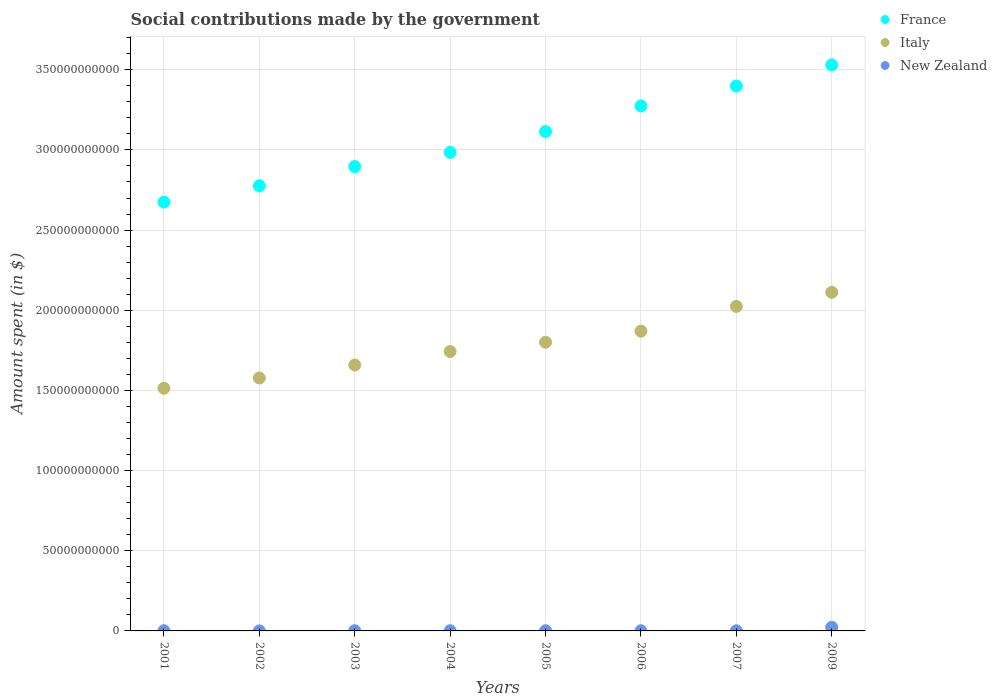How many different coloured dotlines are there?
Ensure brevity in your answer.  3. Is the number of dotlines equal to the number of legend labels?
Offer a very short reply. Yes. What is the amount spent on social contributions in Italy in 2002?
Your answer should be very brief. 1.58e+11. Across all years, what is the maximum amount spent on social contributions in Italy?
Ensure brevity in your answer.  2.11e+11. Across all years, what is the minimum amount spent on social contributions in France?
Ensure brevity in your answer.  2.67e+11. In which year was the amount spent on social contributions in Italy maximum?
Provide a succinct answer. 2009. What is the total amount spent on social contributions in France in the graph?
Offer a terse response. 2.46e+12. What is the difference between the amount spent on social contributions in France in 2005 and that in 2006?
Provide a short and direct response. -1.60e+1. What is the difference between the amount spent on social contributions in Italy in 2002 and the amount spent on social contributions in France in 2007?
Your answer should be compact. -1.82e+11. What is the average amount spent on social contributions in New Zealand per year?
Make the answer very short. 3.73e+08. In the year 2007, what is the difference between the amount spent on social contributions in New Zealand and amount spent on social contributions in France?
Your response must be concise. -3.40e+11. What is the ratio of the amount spent on social contributions in Italy in 2001 to that in 2009?
Your answer should be very brief. 0.72. Is the amount spent on social contributions in France in 2006 less than that in 2009?
Ensure brevity in your answer.  Yes. Is the difference between the amount spent on social contributions in New Zealand in 2006 and 2007 greater than the difference between the amount spent on social contributions in France in 2006 and 2007?
Give a very brief answer. Yes. What is the difference between the highest and the second highest amount spent on social contributions in Italy?
Offer a terse response. 8.82e+09. What is the difference between the highest and the lowest amount spent on social contributions in New Zealand?
Offer a terse response. 2.25e+09. In how many years, is the amount spent on social contributions in France greater than the average amount spent on social contributions in France taken over all years?
Your answer should be very brief. 4. Is the sum of the amount spent on social contributions in New Zealand in 2002 and 2009 greater than the maximum amount spent on social contributions in Italy across all years?
Make the answer very short. No. Is it the case that in every year, the sum of the amount spent on social contributions in France and amount spent on social contributions in New Zealand  is greater than the amount spent on social contributions in Italy?
Ensure brevity in your answer.  Yes. Is the amount spent on social contributions in France strictly less than the amount spent on social contributions in Italy over the years?
Give a very brief answer. No. How many dotlines are there?
Offer a terse response. 3. What is the difference between two consecutive major ticks on the Y-axis?
Your response must be concise. 5.00e+1. Are the values on the major ticks of Y-axis written in scientific E-notation?
Offer a very short reply. No. Does the graph contain any zero values?
Offer a very short reply. No. Does the graph contain grids?
Your answer should be very brief. Yes. How are the legend labels stacked?
Offer a terse response. Vertical. What is the title of the graph?
Your answer should be compact. Social contributions made by the government. What is the label or title of the Y-axis?
Keep it short and to the point. Amount spent (in $). What is the Amount spent (in $) in France in 2001?
Provide a succinct answer. 2.67e+11. What is the Amount spent (in $) of Italy in 2001?
Ensure brevity in your answer.  1.51e+11. What is the Amount spent (in $) in New Zealand in 2001?
Make the answer very short. 1.20e+08. What is the Amount spent (in $) of France in 2002?
Provide a short and direct response. 2.78e+11. What is the Amount spent (in $) in Italy in 2002?
Your answer should be very brief. 1.58e+11. What is the Amount spent (in $) of New Zealand in 2002?
Provide a succinct answer. 2.39e+07. What is the Amount spent (in $) of France in 2003?
Offer a very short reply. 2.90e+11. What is the Amount spent (in $) of Italy in 2003?
Your response must be concise. 1.66e+11. What is the Amount spent (in $) of New Zealand in 2003?
Provide a succinct answer. 1.32e+08. What is the Amount spent (in $) in France in 2004?
Provide a short and direct response. 2.98e+11. What is the Amount spent (in $) in Italy in 2004?
Provide a short and direct response. 1.74e+11. What is the Amount spent (in $) in New Zealand in 2004?
Make the answer very short. 1.13e+08. What is the Amount spent (in $) in France in 2005?
Keep it short and to the point. 3.11e+11. What is the Amount spent (in $) of Italy in 2005?
Ensure brevity in your answer.  1.80e+11. What is the Amount spent (in $) of New Zealand in 2005?
Ensure brevity in your answer.  1.07e+08. What is the Amount spent (in $) in France in 2006?
Your response must be concise. 3.27e+11. What is the Amount spent (in $) in Italy in 2006?
Provide a succinct answer. 1.87e+11. What is the Amount spent (in $) in New Zealand in 2006?
Your answer should be very brief. 1.09e+08. What is the Amount spent (in $) in France in 2007?
Offer a terse response. 3.40e+11. What is the Amount spent (in $) of Italy in 2007?
Offer a very short reply. 2.02e+11. What is the Amount spent (in $) in New Zealand in 2007?
Provide a short and direct response. 1.01e+08. What is the Amount spent (in $) in France in 2009?
Keep it short and to the point. 3.53e+11. What is the Amount spent (in $) in Italy in 2009?
Ensure brevity in your answer.  2.11e+11. What is the Amount spent (in $) of New Zealand in 2009?
Make the answer very short. 2.28e+09. Across all years, what is the maximum Amount spent (in $) in France?
Your response must be concise. 3.53e+11. Across all years, what is the maximum Amount spent (in $) of Italy?
Keep it short and to the point. 2.11e+11. Across all years, what is the maximum Amount spent (in $) of New Zealand?
Provide a succinct answer. 2.28e+09. Across all years, what is the minimum Amount spent (in $) of France?
Your answer should be very brief. 2.67e+11. Across all years, what is the minimum Amount spent (in $) in Italy?
Your response must be concise. 1.51e+11. Across all years, what is the minimum Amount spent (in $) of New Zealand?
Your answer should be compact. 2.39e+07. What is the total Amount spent (in $) of France in the graph?
Make the answer very short. 2.46e+12. What is the total Amount spent (in $) of Italy in the graph?
Keep it short and to the point. 1.43e+12. What is the total Amount spent (in $) of New Zealand in the graph?
Provide a short and direct response. 2.98e+09. What is the difference between the Amount spent (in $) of France in 2001 and that in 2002?
Your answer should be very brief. -1.02e+1. What is the difference between the Amount spent (in $) in Italy in 2001 and that in 2002?
Give a very brief answer. -6.39e+09. What is the difference between the Amount spent (in $) in New Zealand in 2001 and that in 2002?
Provide a short and direct response. 9.61e+07. What is the difference between the Amount spent (in $) in France in 2001 and that in 2003?
Offer a very short reply. -2.22e+1. What is the difference between the Amount spent (in $) of Italy in 2001 and that in 2003?
Give a very brief answer. -1.45e+1. What is the difference between the Amount spent (in $) in New Zealand in 2001 and that in 2003?
Provide a short and direct response. -1.18e+07. What is the difference between the Amount spent (in $) in France in 2001 and that in 2004?
Make the answer very short. -3.10e+1. What is the difference between the Amount spent (in $) in Italy in 2001 and that in 2004?
Your answer should be very brief. -2.29e+1. What is the difference between the Amount spent (in $) of New Zealand in 2001 and that in 2004?
Your response must be concise. 7.25e+06. What is the difference between the Amount spent (in $) of France in 2001 and that in 2005?
Ensure brevity in your answer.  -4.40e+1. What is the difference between the Amount spent (in $) of Italy in 2001 and that in 2005?
Make the answer very short. -2.87e+1. What is the difference between the Amount spent (in $) of New Zealand in 2001 and that in 2005?
Provide a short and direct response. 1.33e+07. What is the difference between the Amount spent (in $) in France in 2001 and that in 2006?
Provide a succinct answer. -6.00e+1. What is the difference between the Amount spent (in $) of Italy in 2001 and that in 2006?
Your response must be concise. -3.56e+1. What is the difference between the Amount spent (in $) of New Zealand in 2001 and that in 2006?
Your answer should be very brief. 1.10e+07. What is the difference between the Amount spent (in $) in France in 2001 and that in 2007?
Provide a short and direct response. -7.24e+1. What is the difference between the Amount spent (in $) of Italy in 2001 and that in 2007?
Provide a succinct answer. -5.10e+1. What is the difference between the Amount spent (in $) in New Zealand in 2001 and that in 2007?
Your answer should be compact. 1.90e+07. What is the difference between the Amount spent (in $) in France in 2001 and that in 2009?
Offer a very short reply. -8.56e+1. What is the difference between the Amount spent (in $) in Italy in 2001 and that in 2009?
Your answer should be very brief. -5.98e+1. What is the difference between the Amount spent (in $) in New Zealand in 2001 and that in 2009?
Ensure brevity in your answer.  -2.16e+09. What is the difference between the Amount spent (in $) of France in 2002 and that in 2003?
Your answer should be compact. -1.20e+1. What is the difference between the Amount spent (in $) in Italy in 2002 and that in 2003?
Provide a short and direct response. -8.11e+09. What is the difference between the Amount spent (in $) of New Zealand in 2002 and that in 2003?
Your answer should be very brief. -1.08e+08. What is the difference between the Amount spent (in $) of France in 2002 and that in 2004?
Offer a very short reply. -2.08e+1. What is the difference between the Amount spent (in $) in Italy in 2002 and that in 2004?
Give a very brief answer. -1.65e+1. What is the difference between the Amount spent (in $) in New Zealand in 2002 and that in 2004?
Give a very brief answer. -8.89e+07. What is the difference between the Amount spent (in $) of France in 2002 and that in 2005?
Offer a very short reply. -3.38e+1. What is the difference between the Amount spent (in $) of Italy in 2002 and that in 2005?
Give a very brief answer. -2.23e+1. What is the difference between the Amount spent (in $) in New Zealand in 2002 and that in 2005?
Provide a short and direct response. -8.29e+07. What is the difference between the Amount spent (in $) of France in 2002 and that in 2006?
Provide a succinct answer. -4.98e+1. What is the difference between the Amount spent (in $) in Italy in 2002 and that in 2006?
Give a very brief answer. -2.92e+1. What is the difference between the Amount spent (in $) in New Zealand in 2002 and that in 2006?
Offer a very short reply. -8.51e+07. What is the difference between the Amount spent (in $) in France in 2002 and that in 2007?
Your response must be concise. -6.22e+1. What is the difference between the Amount spent (in $) of Italy in 2002 and that in 2007?
Provide a succinct answer. -4.46e+1. What is the difference between the Amount spent (in $) of New Zealand in 2002 and that in 2007?
Offer a very short reply. -7.71e+07. What is the difference between the Amount spent (in $) in France in 2002 and that in 2009?
Offer a terse response. -7.54e+1. What is the difference between the Amount spent (in $) of Italy in 2002 and that in 2009?
Your answer should be very brief. -5.35e+1. What is the difference between the Amount spent (in $) of New Zealand in 2002 and that in 2009?
Give a very brief answer. -2.25e+09. What is the difference between the Amount spent (in $) in France in 2003 and that in 2004?
Offer a very short reply. -8.82e+09. What is the difference between the Amount spent (in $) in Italy in 2003 and that in 2004?
Your response must be concise. -8.40e+09. What is the difference between the Amount spent (in $) of New Zealand in 2003 and that in 2004?
Your answer should be very brief. 1.91e+07. What is the difference between the Amount spent (in $) of France in 2003 and that in 2005?
Keep it short and to the point. -2.18e+1. What is the difference between the Amount spent (in $) of Italy in 2003 and that in 2005?
Your answer should be compact. -1.42e+1. What is the difference between the Amount spent (in $) in New Zealand in 2003 and that in 2005?
Keep it short and to the point. 2.51e+07. What is the difference between the Amount spent (in $) of France in 2003 and that in 2006?
Provide a succinct answer. -3.78e+1. What is the difference between the Amount spent (in $) of Italy in 2003 and that in 2006?
Provide a short and direct response. -2.11e+1. What is the difference between the Amount spent (in $) of New Zealand in 2003 and that in 2006?
Give a very brief answer. 2.28e+07. What is the difference between the Amount spent (in $) of France in 2003 and that in 2007?
Give a very brief answer. -5.03e+1. What is the difference between the Amount spent (in $) of Italy in 2003 and that in 2007?
Give a very brief answer. -3.65e+1. What is the difference between the Amount spent (in $) in New Zealand in 2003 and that in 2007?
Make the answer very short. 3.08e+07. What is the difference between the Amount spent (in $) of France in 2003 and that in 2009?
Keep it short and to the point. -6.34e+1. What is the difference between the Amount spent (in $) of Italy in 2003 and that in 2009?
Give a very brief answer. -4.53e+1. What is the difference between the Amount spent (in $) of New Zealand in 2003 and that in 2009?
Your response must be concise. -2.15e+09. What is the difference between the Amount spent (in $) in France in 2004 and that in 2005?
Keep it short and to the point. -1.30e+1. What is the difference between the Amount spent (in $) in Italy in 2004 and that in 2005?
Your answer should be compact. -5.80e+09. What is the difference between the Amount spent (in $) in New Zealand in 2004 and that in 2005?
Provide a succinct answer. 6.02e+06. What is the difference between the Amount spent (in $) in France in 2004 and that in 2006?
Provide a short and direct response. -2.90e+1. What is the difference between the Amount spent (in $) in Italy in 2004 and that in 2006?
Keep it short and to the point. -1.27e+1. What is the difference between the Amount spent (in $) of New Zealand in 2004 and that in 2006?
Give a very brief answer. 3.75e+06. What is the difference between the Amount spent (in $) in France in 2004 and that in 2007?
Give a very brief answer. -4.14e+1. What is the difference between the Amount spent (in $) in Italy in 2004 and that in 2007?
Offer a very short reply. -2.81e+1. What is the difference between the Amount spent (in $) in New Zealand in 2004 and that in 2007?
Give a very brief answer. 1.18e+07. What is the difference between the Amount spent (in $) of France in 2004 and that in 2009?
Keep it short and to the point. -5.46e+1. What is the difference between the Amount spent (in $) of Italy in 2004 and that in 2009?
Provide a short and direct response. -3.69e+1. What is the difference between the Amount spent (in $) in New Zealand in 2004 and that in 2009?
Your answer should be compact. -2.17e+09. What is the difference between the Amount spent (in $) of France in 2005 and that in 2006?
Provide a short and direct response. -1.60e+1. What is the difference between the Amount spent (in $) of Italy in 2005 and that in 2006?
Your answer should be very brief. -6.89e+09. What is the difference between the Amount spent (in $) of New Zealand in 2005 and that in 2006?
Keep it short and to the point. -2.26e+06. What is the difference between the Amount spent (in $) of France in 2005 and that in 2007?
Keep it short and to the point. -2.84e+1. What is the difference between the Amount spent (in $) in Italy in 2005 and that in 2007?
Your answer should be very brief. -2.23e+1. What is the difference between the Amount spent (in $) in New Zealand in 2005 and that in 2007?
Your answer should be compact. 5.74e+06. What is the difference between the Amount spent (in $) in France in 2005 and that in 2009?
Provide a short and direct response. -4.16e+1. What is the difference between the Amount spent (in $) of Italy in 2005 and that in 2009?
Offer a terse response. -3.11e+1. What is the difference between the Amount spent (in $) of New Zealand in 2005 and that in 2009?
Your response must be concise. -2.17e+09. What is the difference between the Amount spent (in $) of France in 2006 and that in 2007?
Keep it short and to the point. -1.24e+1. What is the difference between the Amount spent (in $) of Italy in 2006 and that in 2007?
Give a very brief answer. -1.54e+1. What is the difference between the Amount spent (in $) of France in 2006 and that in 2009?
Keep it short and to the point. -2.56e+1. What is the difference between the Amount spent (in $) in Italy in 2006 and that in 2009?
Offer a terse response. -2.43e+1. What is the difference between the Amount spent (in $) of New Zealand in 2006 and that in 2009?
Offer a terse response. -2.17e+09. What is the difference between the Amount spent (in $) of France in 2007 and that in 2009?
Your answer should be compact. -1.32e+1. What is the difference between the Amount spent (in $) in Italy in 2007 and that in 2009?
Offer a very short reply. -8.82e+09. What is the difference between the Amount spent (in $) in New Zealand in 2007 and that in 2009?
Keep it short and to the point. -2.18e+09. What is the difference between the Amount spent (in $) in France in 2001 and the Amount spent (in $) in Italy in 2002?
Your response must be concise. 1.10e+11. What is the difference between the Amount spent (in $) in France in 2001 and the Amount spent (in $) in New Zealand in 2002?
Make the answer very short. 2.67e+11. What is the difference between the Amount spent (in $) in Italy in 2001 and the Amount spent (in $) in New Zealand in 2002?
Offer a terse response. 1.51e+11. What is the difference between the Amount spent (in $) of France in 2001 and the Amount spent (in $) of Italy in 2003?
Offer a very short reply. 1.02e+11. What is the difference between the Amount spent (in $) of France in 2001 and the Amount spent (in $) of New Zealand in 2003?
Your answer should be compact. 2.67e+11. What is the difference between the Amount spent (in $) in Italy in 2001 and the Amount spent (in $) in New Zealand in 2003?
Your answer should be very brief. 1.51e+11. What is the difference between the Amount spent (in $) in France in 2001 and the Amount spent (in $) in Italy in 2004?
Your answer should be compact. 9.32e+1. What is the difference between the Amount spent (in $) of France in 2001 and the Amount spent (in $) of New Zealand in 2004?
Keep it short and to the point. 2.67e+11. What is the difference between the Amount spent (in $) in Italy in 2001 and the Amount spent (in $) in New Zealand in 2004?
Provide a short and direct response. 1.51e+11. What is the difference between the Amount spent (in $) of France in 2001 and the Amount spent (in $) of Italy in 2005?
Give a very brief answer. 8.74e+1. What is the difference between the Amount spent (in $) in France in 2001 and the Amount spent (in $) in New Zealand in 2005?
Ensure brevity in your answer.  2.67e+11. What is the difference between the Amount spent (in $) of Italy in 2001 and the Amount spent (in $) of New Zealand in 2005?
Your answer should be very brief. 1.51e+11. What is the difference between the Amount spent (in $) of France in 2001 and the Amount spent (in $) of Italy in 2006?
Your response must be concise. 8.05e+1. What is the difference between the Amount spent (in $) in France in 2001 and the Amount spent (in $) in New Zealand in 2006?
Your response must be concise. 2.67e+11. What is the difference between the Amount spent (in $) in Italy in 2001 and the Amount spent (in $) in New Zealand in 2006?
Make the answer very short. 1.51e+11. What is the difference between the Amount spent (in $) in France in 2001 and the Amount spent (in $) in Italy in 2007?
Provide a short and direct response. 6.50e+1. What is the difference between the Amount spent (in $) in France in 2001 and the Amount spent (in $) in New Zealand in 2007?
Make the answer very short. 2.67e+11. What is the difference between the Amount spent (in $) of Italy in 2001 and the Amount spent (in $) of New Zealand in 2007?
Make the answer very short. 1.51e+11. What is the difference between the Amount spent (in $) in France in 2001 and the Amount spent (in $) in Italy in 2009?
Offer a very short reply. 5.62e+1. What is the difference between the Amount spent (in $) of France in 2001 and the Amount spent (in $) of New Zealand in 2009?
Provide a short and direct response. 2.65e+11. What is the difference between the Amount spent (in $) in Italy in 2001 and the Amount spent (in $) in New Zealand in 2009?
Offer a very short reply. 1.49e+11. What is the difference between the Amount spent (in $) of France in 2002 and the Amount spent (in $) of Italy in 2003?
Your answer should be very brief. 1.12e+11. What is the difference between the Amount spent (in $) of France in 2002 and the Amount spent (in $) of New Zealand in 2003?
Your answer should be compact. 2.77e+11. What is the difference between the Amount spent (in $) in Italy in 2002 and the Amount spent (in $) in New Zealand in 2003?
Provide a short and direct response. 1.58e+11. What is the difference between the Amount spent (in $) in France in 2002 and the Amount spent (in $) in Italy in 2004?
Offer a very short reply. 1.03e+11. What is the difference between the Amount spent (in $) in France in 2002 and the Amount spent (in $) in New Zealand in 2004?
Offer a terse response. 2.78e+11. What is the difference between the Amount spent (in $) of Italy in 2002 and the Amount spent (in $) of New Zealand in 2004?
Keep it short and to the point. 1.58e+11. What is the difference between the Amount spent (in $) of France in 2002 and the Amount spent (in $) of Italy in 2005?
Offer a terse response. 9.76e+1. What is the difference between the Amount spent (in $) of France in 2002 and the Amount spent (in $) of New Zealand in 2005?
Your response must be concise. 2.78e+11. What is the difference between the Amount spent (in $) of Italy in 2002 and the Amount spent (in $) of New Zealand in 2005?
Ensure brevity in your answer.  1.58e+11. What is the difference between the Amount spent (in $) in France in 2002 and the Amount spent (in $) in Italy in 2006?
Provide a short and direct response. 9.07e+1. What is the difference between the Amount spent (in $) of France in 2002 and the Amount spent (in $) of New Zealand in 2006?
Offer a very short reply. 2.78e+11. What is the difference between the Amount spent (in $) in Italy in 2002 and the Amount spent (in $) in New Zealand in 2006?
Your response must be concise. 1.58e+11. What is the difference between the Amount spent (in $) of France in 2002 and the Amount spent (in $) of Italy in 2007?
Give a very brief answer. 7.52e+1. What is the difference between the Amount spent (in $) in France in 2002 and the Amount spent (in $) in New Zealand in 2007?
Keep it short and to the point. 2.78e+11. What is the difference between the Amount spent (in $) in Italy in 2002 and the Amount spent (in $) in New Zealand in 2007?
Provide a short and direct response. 1.58e+11. What is the difference between the Amount spent (in $) of France in 2002 and the Amount spent (in $) of Italy in 2009?
Offer a terse response. 6.64e+1. What is the difference between the Amount spent (in $) in France in 2002 and the Amount spent (in $) in New Zealand in 2009?
Give a very brief answer. 2.75e+11. What is the difference between the Amount spent (in $) of Italy in 2002 and the Amount spent (in $) of New Zealand in 2009?
Offer a very short reply. 1.55e+11. What is the difference between the Amount spent (in $) in France in 2003 and the Amount spent (in $) in Italy in 2004?
Offer a terse response. 1.15e+11. What is the difference between the Amount spent (in $) in France in 2003 and the Amount spent (in $) in New Zealand in 2004?
Ensure brevity in your answer.  2.90e+11. What is the difference between the Amount spent (in $) of Italy in 2003 and the Amount spent (in $) of New Zealand in 2004?
Provide a succinct answer. 1.66e+11. What is the difference between the Amount spent (in $) in France in 2003 and the Amount spent (in $) in Italy in 2005?
Offer a very short reply. 1.10e+11. What is the difference between the Amount spent (in $) in France in 2003 and the Amount spent (in $) in New Zealand in 2005?
Offer a terse response. 2.90e+11. What is the difference between the Amount spent (in $) of Italy in 2003 and the Amount spent (in $) of New Zealand in 2005?
Provide a short and direct response. 1.66e+11. What is the difference between the Amount spent (in $) in France in 2003 and the Amount spent (in $) in Italy in 2006?
Make the answer very short. 1.03e+11. What is the difference between the Amount spent (in $) of France in 2003 and the Amount spent (in $) of New Zealand in 2006?
Offer a terse response. 2.90e+11. What is the difference between the Amount spent (in $) in Italy in 2003 and the Amount spent (in $) in New Zealand in 2006?
Provide a succinct answer. 1.66e+11. What is the difference between the Amount spent (in $) of France in 2003 and the Amount spent (in $) of Italy in 2007?
Offer a very short reply. 8.72e+1. What is the difference between the Amount spent (in $) in France in 2003 and the Amount spent (in $) in New Zealand in 2007?
Ensure brevity in your answer.  2.90e+11. What is the difference between the Amount spent (in $) of Italy in 2003 and the Amount spent (in $) of New Zealand in 2007?
Keep it short and to the point. 1.66e+11. What is the difference between the Amount spent (in $) in France in 2003 and the Amount spent (in $) in Italy in 2009?
Provide a short and direct response. 7.84e+1. What is the difference between the Amount spent (in $) of France in 2003 and the Amount spent (in $) of New Zealand in 2009?
Your answer should be compact. 2.87e+11. What is the difference between the Amount spent (in $) of Italy in 2003 and the Amount spent (in $) of New Zealand in 2009?
Keep it short and to the point. 1.64e+11. What is the difference between the Amount spent (in $) in France in 2004 and the Amount spent (in $) in Italy in 2005?
Make the answer very short. 1.18e+11. What is the difference between the Amount spent (in $) in France in 2004 and the Amount spent (in $) in New Zealand in 2005?
Offer a terse response. 2.98e+11. What is the difference between the Amount spent (in $) of Italy in 2004 and the Amount spent (in $) of New Zealand in 2005?
Give a very brief answer. 1.74e+11. What is the difference between the Amount spent (in $) in France in 2004 and the Amount spent (in $) in Italy in 2006?
Offer a very short reply. 1.11e+11. What is the difference between the Amount spent (in $) in France in 2004 and the Amount spent (in $) in New Zealand in 2006?
Your answer should be very brief. 2.98e+11. What is the difference between the Amount spent (in $) of Italy in 2004 and the Amount spent (in $) of New Zealand in 2006?
Offer a terse response. 1.74e+11. What is the difference between the Amount spent (in $) of France in 2004 and the Amount spent (in $) of Italy in 2007?
Give a very brief answer. 9.60e+1. What is the difference between the Amount spent (in $) in France in 2004 and the Amount spent (in $) in New Zealand in 2007?
Make the answer very short. 2.98e+11. What is the difference between the Amount spent (in $) in Italy in 2004 and the Amount spent (in $) in New Zealand in 2007?
Provide a short and direct response. 1.74e+11. What is the difference between the Amount spent (in $) in France in 2004 and the Amount spent (in $) in Italy in 2009?
Make the answer very short. 8.72e+1. What is the difference between the Amount spent (in $) in France in 2004 and the Amount spent (in $) in New Zealand in 2009?
Provide a succinct answer. 2.96e+11. What is the difference between the Amount spent (in $) of Italy in 2004 and the Amount spent (in $) of New Zealand in 2009?
Offer a terse response. 1.72e+11. What is the difference between the Amount spent (in $) of France in 2005 and the Amount spent (in $) of Italy in 2006?
Offer a very short reply. 1.24e+11. What is the difference between the Amount spent (in $) in France in 2005 and the Amount spent (in $) in New Zealand in 2006?
Provide a short and direct response. 3.11e+11. What is the difference between the Amount spent (in $) of Italy in 2005 and the Amount spent (in $) of New Zealand in 2006?
Ensure brevity in your answer.  1.80e+11. What is the difference between the Amount spent (in $) in France in 2005 and the Amount spent (in $) in Italy in 2007?
Ensure brevity in your answer.  1.09e+11. What is the difference between the Amount spent (in $) of France in 2005 and the Amount spent (in $) of New Zealand in 2007?
Your answer should be compact. 3.11e+11. What is the difference between the Amount spent (in $) of Italy in 2005 and the Amount spent (in $) of New Zealand in 2007?
Offer a very short reply. 1.80e+11. What is the difference between the Amount spent (in $) of France in 2005 and the Amount spent (in $) of Italy in 2009?
Provide a short and direct response. 1.00e+11. What is the difference between the Amount spent (in $) of France in 2005 and the Amount spent (in $) of New Zealand in 2009?
Your response must be concise. 3.09e+11. What is the difference between the Amount spent (in $) in Italy in 2005 and the Amount spent (in $) in New Zealand in 2009?
Provide a succinct answer. 1.78e+11. What is the difference between the Amount spent (in $) in France in 2006 and the Amount spent (in $) in Italy in 2007?
Offer a very short reply. 1.25e+11. What is the difference between the Amount spent (in $) of France in 2006 and the Amount spent (in $) of New Zealand in 2007?
Your answer should be very brief. 3.27e+11. What is the difference between the Amount spent (in $) of Italy in 2006 and the Amount spent (in $) of New Zealand in 2007?
Provide a short and direct response. 1.87e+11. What is the difference between the Amount spent (in $) of France in 2006 and the Amount spent (in $) of Italy in 2009?
Keep it short and to the point. 1.16e+11. What is the difference between the Amount spent (in $) in France in 2006 and the Amount spent (in $) in New Zealand in 2009?
Your answer should be compact. 3.25e+11. What is the difference between the Amount spent (in $) in Italy in 2006 and the Amount spent (in $) in New Zealand in 2009?
Provide a succinct answer. 1.85e+11. What is the difference between the Amount spent (in $) in France in 2007 and the Amount spent (in $) in Italy in 2009?
Offer a terse response. 1.29e+11. What is the difference between the Amount spent (in $) in France in 2007 and the Amount spent (in $) in New Zealand in 2009?
Provide a succinct answer. 3.38e+11. What is the difference between the Amount spent (in $) of Italy in 2007 and the Amount spent (in $) of New Zealand in 2009?
Your answer should be compact. 2.00e+11. What is the average Amount spent (in $) of France per year?
Make the answer very short. 3.08e+11. What is the average Amount spent (in $) in Italy per year?
Make the answer very short. 1.79e+11. What is the average Amount spent (in $) of New Zealand per year?
Make the answer very short. 3.73e+08. In the year 2001, what is the difference between the Amount spent (in $) in France and Amount spent (in $) in Italy?
Make the answer very short. 1.16e+11. In the year 2001, what is the difference between the Amount spent (in $) in France and Amount spent (in $) in New Zealand?
Keep it short and to the point. 2.67e+11. In the year 2001, what is the difference between the Amount spent (in $) of Italy and Amount spent (in $) of New Zealand?
Offer a very short reply. 1.51e+11. In the year 2002, what is the difference between the Amount spent (in $) in France and Amount spent (in $) in Italy?
Give a very brief answer. 1.20e+11. In the year 2002, what is the difference between the Amount spent (in $) of France and Amount spent (in $) of New Zealand?
Provide a short and direct response. 2.78e+11. In the year 2002, what is the difference between the Amount spent (in $) of Italy and Amount spent (in $) of New Zealand?
Keep it short and to the point. 1.58e+11. In the year 2003, what is the difference between the Amount spent (in $) of France and Amount spent (in $) of Italy?
Keep it short and to the point. 1.24e+11. In the year 2003, what is the difference between the Amount spent (in $) in France and Amount spent (in $) in New Zealand?
Your answer should be very brief. 2.89e+11. In the year 2003, what is the difference between the Amount spent (in $) of Italy and Amount spent (in $) of New Zealand?
Provide a short and direct response. 1.66e+11. In the year 2004, what is the difference between the Amount spent (in $) of France and Amount spent (in $) of Italy?
Your response must be concise. 1.24e+11. In the year 2004, what is the difference between the Amount spent (in $) in France and Amount spent (in $) in New Zealand?
Your response must be concise. 2.98e+11. In the year 2004, what is the difference between the Amount spent (in $) of Italy and Amount spent (in $) of New Zealand?
Your response must be concise. 1.74e+11. In the year 2005, what is the difference between the Amount spent (in $) in France and Amount spent (in $) in Italy?
Provide a succinct answer. 1.31e+11. In the year 2005, what is the difference between the Amount spent (in $) of France and Amount spent (in $) of New Zealand?
Your answer should be compact. 3.11e+11. In the year 2005, what is the difference between the Amount spent (in $) in Italy and Amount spent (in $) in New Zealand?
Offer a very short reply. 1.80e+11. In the year 2006, what is the difference between the Amount spent (in $) of France and Amount spent (in $) of Italy?
Give a very brief answer. 1.41e+11. In the year 2006, what is the difference between the Amount spent (in $) in France and Amount spent (in $) in New Zealand?
Make the answer very short. 3.27e+11. In the year 2006, what is the difference between the Amount spent (in $) of Italy and Amount spent (in $) of New Zealand?
Provide a succinct answer. 1.87e+11. In the year 2007, what is the difference between the Amount spent (in $) in France and Amount spent (in $) in Italy?
Give a very brief answer. 1.37e+11. In the year 2007, what is the difference between the Amount spent (in $) of France and Amount spent (in $) of New Zealand?
Make the answer very short. 3.40e+11. In the year 2007, what is the difference between the Amount spent (in $) of Italy and Amount spent (in $) of New Zealand?
Your answer should be very brief. 2.02e+11. In the year 2009, what is the difference between the Amount spent (in $) of France and Amount spent (in $) of Italy?
Make the answer very short. 1.42e+11. In the year 2009, what is the difference between the Amount spent (in $) in France and Amount spent (in $) in New Zealand?
Offer a terse response. 3.51e+11. In the year 2009, what is the difference between the Amount spent (in $) of Italy and Amount spent (in $) of New Zealand?
Keep it short and to the point. 2.09e+11. What is the ratio of the Amount spent (in $) in France in 2001 to that in 2002?
Make the answer very short. 0.96. What is the ratio of the Amount spent (in $) in Italy in 2001 to that in 2002?
Provide a succinct answer. 0.96. What is the ratio of the Amount spent (in $) in New Zealand in 2001 to that in 2002?
Offer a terse response. 5.03. What is the ratio of the Amount spent (in $) of France in 2001 to that in 2003?
Your answer should be very brief. 0.92. What is the ratio of the Amount spent (in $) of Italy in 2001 to that in 2003?
Your response must be concise. 0.91. What is the ratio of the Amount spent (in $) in New Zealand in 2001 to that in 2003?
Give a very brief answer. 0.91. What is the ratio of the Amount spent (in $) of France in 2001 to that in 2004?
Offer a very short reply. 0.9. What is the ratio of the Amount spent (in $) in Italy in 2001 to that in 2004?
Ensure brevity in your answer.  0.87. What is the ratio of the Amount spent (in $) of New Zealand in 2001 to that in 2004?
Provide a succinct answer. 1.06. What is the ratio of the Amount spent (in $) in France in 2001 to that in 2005?
Your response must be concise. 0.86. What is the ratio of the Amount spent (in $) in Italy in 2001 to that in 2005?
Ensure brevity in your answer.  0.84. What is the ratio of the Amount spent (in $) of New Zealand in 2001 to that in 2005?
Provide a succinct answer. 1.12. What is the ratio of the Amount spent (in $) of France in 2001 to that in 2006?
Your answer should be compact. 0.82. What is the ratio of the Amount spent (in $) of Italy in 2001 to that in 2006?
Offer a terse response. 0.81. What is the ratio of the Amount spent (in $) in New Zealand in 2001 to that in 2006?
Make the answer very short. 1.1. What is the ratio of the Amount spent (in $) of France in 2001 to that in 2007?
Offer a very short reply. 0.79. What is the ratio of the Amount spent (in $) of Italy in 2001 to that in 2007?
Give a very brief answer. 0.75. What is the ratio of the Amount spent (in $) of New Zealand in 2001 to that in 2007?
Provide a short and direct response. 1.19. What is the ratio of the Amount spent (in $) of France in 2001 to that in 2009?
Keep it short and to the point. 0.76. What is the ratio of the Amount spent (in $) of Italy in 2001 to that in 2009?
Offer a terse response. 0.72. What is the ratio of the Amount spent (in $) in New Zealand in 2001 to that in 2009?
Your response must be concise. 0.05. What is the ratio of the Amount spent (in $) of France in 2002 to that in 2003?
Your response must be concise. 0.96. What is the ratio of the Amount spent (in $) in Italy in 2002 to that in 2003?
Your response must be concise. 0.95. What is the ratio of the Amount spent (in $) in New Zealand in 2002 to that in 2003?
Your response must be concise. 0.18. What is the ratio of the Amount spent (in $) in France in 2002 to that in 2004?
Offer a very short reply. 0.93. What is the ratio of the Amount spent (in $) in Italy in 2002 to that in 2004?
Offer a very short reply. 0.91. What is the ratio of the Amount spent (in $) of New Zealand in 2002 to that in 2004?
Your response must be concise. 0.21. What is the ratio of the Amount spent (in $) in France in 2002 to that in 2005?
Make the answer very short. 0.89. What is the ratio of the Amount spent (in $) in Italy in 2002 to that in 2005?
Your response must be concise. 0.88. What is the ratio of the Amount spent (in $) of New Zealand in 2002 to that in 2005?
Your response must be concise. 0.22. What is the ratio of the Amount spent (in $) of France in 2002 to that in 2006?
Provide a succinct answer. 0.85. What is the ratio of the Amount spent (in $) in Italy in 2002 to that in 2006?
Keep it short and to the point. 0.84. What is the ratio of the Amount spent (in $) of New Zealand in 2002 to that in 2006?
Ensure brevity in your answer.  0.22. What is the ratio of the Amount spent (in $) of France in 2002 to that in 2007?
Keep it short and to the point. 0.82. What is the ratio of the Amount spent (in $) in Italy in 2002 to that in 2007?
Your response must be concise. 0.78. What is the ratio of the Amount spent (in $) of New Zealand in 2002 to that in 2007?
Offer a very short reply. 0.24. What is the ratio of the Amount spent (in $) of France in 2002 to that in 2009?
Keep it short and to the point. 0.79. What is the ratio of the Amount spent (in $) in Italy in 2002 to that in 2009?
Give a very brief answer. 0.75. What is the ratio of the Amount spent (in $) of New Zealand in 2002 to that in 2009?
Your answer should be very brief. 0.01. What is the ratio of the Amount spent (in $) in France in 2003 to that in 2004?
Offer a terse response. 0.97. What is the ratio of the Amount spent (in $) of Italy in 2003 to that in 2004?
Your response must be concise. 0.95. What is the ratio of the Amount spent (in $) of New Zealand in 2003 to that in 2004?
Make the answer very short. 1.17. What is the ratio of the Amount spent (in $) in France in 2003 to that in 2005?
Provide a succinct answer. 0.93. What is the ratio of the Amount spent (in $) of Italy in 2003 to that in 2005?
Offer a terse response. 0.92. What is the ratio of the Amount spent (in $) in New Zealand in 2003 to that in 2005?
Your answer should be compact. 1.24. What is the ratio of the Amount spent (in $) of France in 2003 to that in 2006?
Provide a succinct answer. 0.88. What is the ratio of the Amount spent (in $) of Italy in 2003 to that in 2006?
Ensure brevity in your answer.  0.89. What is the ratio of the Amount spent (in $) of New Zealand in 2003 to that in 2006?
Give a very brief answer. 1.21. What is the ratio of the Amount spent (in $) of France in 2003 to that in 2007?
Provide a short and direct response. 0.85. What is the ratio of the Amount spent (in $) in Italy in 2003 to that in 2007?
Keep it short and to the point. 0.82. What is the ratio of the Amount spent (in $) in New Zealand in 2003 to that in 2007?
Offer a very short reply. 1.31. What is the ratio of the Amount spent (in $) in France in 2003 to that in 2009?
Offer a very short reply. 0.82. What is the ratio of the Amount spent (in $) of Italy in 2003 to that in 2009?
Your answer should be compact. 0.79. What is the ratio of the Amount spent (in $) in New Zealand in 2003 to that in 2009?
Ensure brevity in your answer.  0.06. What is the ratio of the Amount spent (in $) in France in 2004 to that in 2005?
Make the answer very short. 0.96. What is the ratio of the Amount spent (in $) in Italy in 2004 to that in 2005?
Keep it short and to the point. 0.97. What is the ratio of the Amount spent (in $) in New Zealand in 2004 to that in 2005?
Offer a very short reply. 1.06. What is the ratio of the Amount spent (in $) in France in 2004 to that in 2006?
Give a very brief answer. 0.91. What is the ratio of the Amount spent (in $) of Italy in 2004 to that in 2006?
Give a very brief answer. 0.93. What is the ratio of the Amount spent (in $) in New Zealand in 2004 to that in 2006?
Provide a short and direct response. 1.03. What is the ratio of the Amount spent (in $) of France in 2004 to that in 2007?
Make the answer very short. 0.88. What is the ratio of the Amount spent (in $) in Italy in 2004 to that in 2007?
Your response must be concise. 0.86. What is the ratio of the Amount spent (in $) in New Zealand in 2004 to that in 2007?
Your answer should be compact. 1.12. What is the ratio of the Amount spent (in $) in France in 2004 to that in 2009?
Offer a terse response. 0.85. What is the ratio of the Amount spent (in $) in Italy in 2004 to that in 2009?
Give a very brief answer. 0.83. What is the ratio of the Amount spent (in $) in New Zealand in 2004 to that in 2009?
Give a very brief answer. 0.05. What is the ratio of the Amount spent (in $) of France in 2005 to that in 2006?
Your response must be concise. 0.95. What is the ratio of the Amount spent (in $) in Italy in 2005 to that in 2006?
Give a very brief answer. 0.96. What is the ratio of the Amount spent (in $) in New Zealand in 2005 to that in 2006?
Keep it short and to the point. 0.98. What is the ratio of the Amount spent (in $) of France in 2005 to that in 2007?
Your answer should be very brief. 0.92. What is the ratio of the Amount spent (in $) of Italy in 2005 to that in 2007?
Give a very brief answer. 0.89. What is the ratio of the Amount spent (in $) of New Zealand in 2005 to that in 2007?
Keep it short and to the point. 1.06. What is the ratio of the Amount spent (in $) in France in 2005 to that in 2009?
Your answer should be very brief. 0.88. What is the ratio of the Amount spent (in $) in Italy in 2005 to that in 2009?
Give a very brief answer. 0.85. What is the ratio of the Amount spent (in $) of New Zealand in 2005 to that in 2009?
Give a very brief answer. 0.05. What is the ratio of the Amount spent (in $) of France in 2006 to that in 2007?
Keep it short and to the point. 0.96. What is the ratio of the Amount spent (in $) in Italy in 2006 to that in 2007?
Provide a succinct answer. 0.92. What is the ratio of the Amount spent (in $) in New Zealand in 2006 to that in 2007?
Offer a terse response. 1.08. What is the ratio of the Amount spent (in $) of France in 2006 to that in 2009?
Give a very brief answer. 0.93. What is the ratio of the Amount spent (in $) in Italy in 2006 to that in 2009?
Ensure brevity in your answer.  0.89. What is the ratio of the Amount spent (in $) in New Zealand in 2006 to that in 2009?
Ensure brevity in your answer.  0.05. What is the ratio of the Amount spent (in $) of France in 2007 to that in 2009?
Make the answer very short. 0.96. What is the ratio of the Amount spent (in $) in Italy in 2007 to that in 2009?
Ensure brevity in your answer.  0.96. What is the ratio of the Amount spent (in $) in New Zealand in 2007 to that in 2009?
Offer a terse response. 0.04. What is the difference between the highest and the second highest Amount spent (in $) of France?
Offer a very short reply. 1.32e+1. What is the difference between the highest and the second highest Amount spent (in $) in Italy?
Offer a terse response. 8.82e+09. What is the difference between the highest and the second highest Amount spent (in $) in New Zealand?
Offer a terse response. 2.15e+09. What is the difference between the highest and the lowest Amount spent (in $) of France?
Offer a terse response. 8.56e+1. What is the difference between the highest and the lowest Amount spent (in $) of Italy?
Your response must be concise. 5.98e+1. What is the difference between the highest and the lowest Amount spent (in $) of New Zealand?
Make the answer very short. 2.25e+09. 